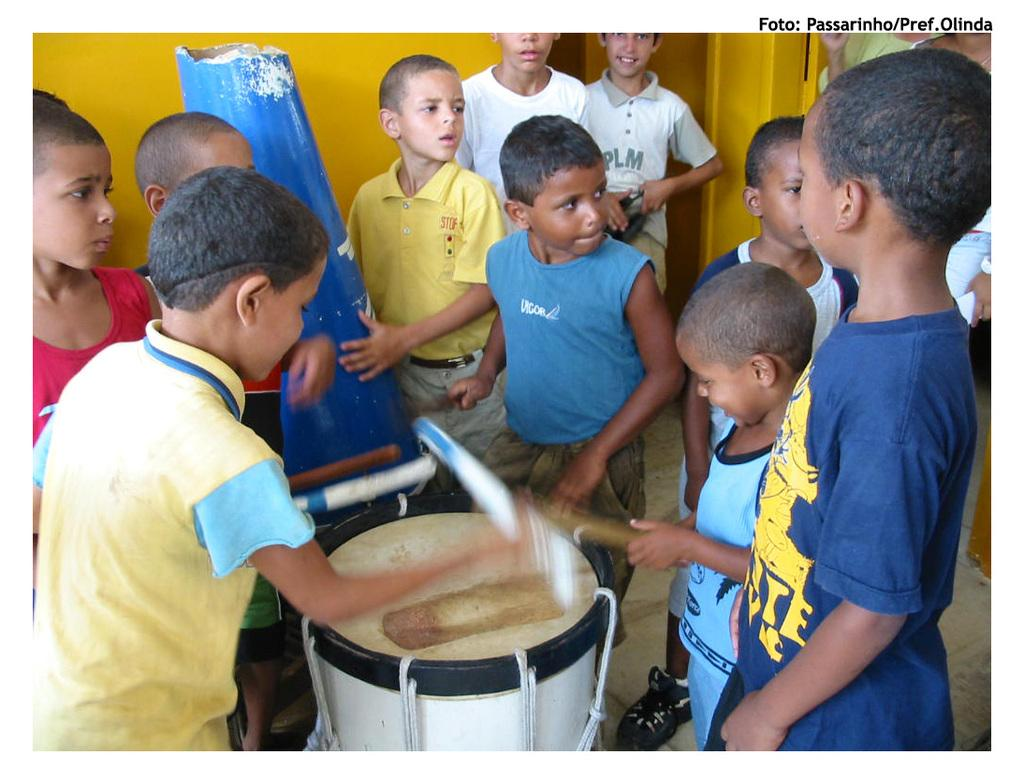How many children are present in the image? There are many children standing in the image. What else can be seen in the image besides the children? There is a musical instrument in the image. Are the children holding balloons in the image? There is no mention of balloons in the image, so we cannot determine if the children are holding any. 